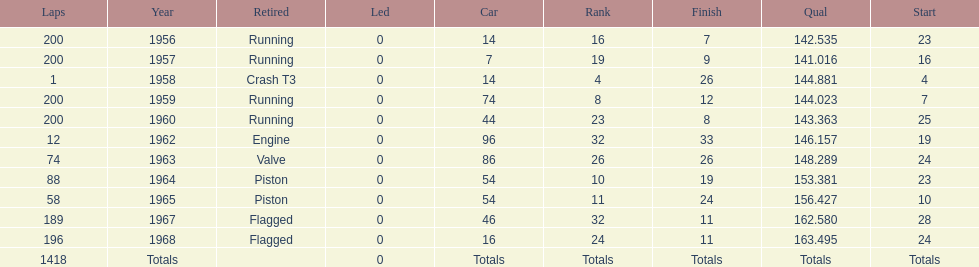What was the last year that it finished the race? 1968. 